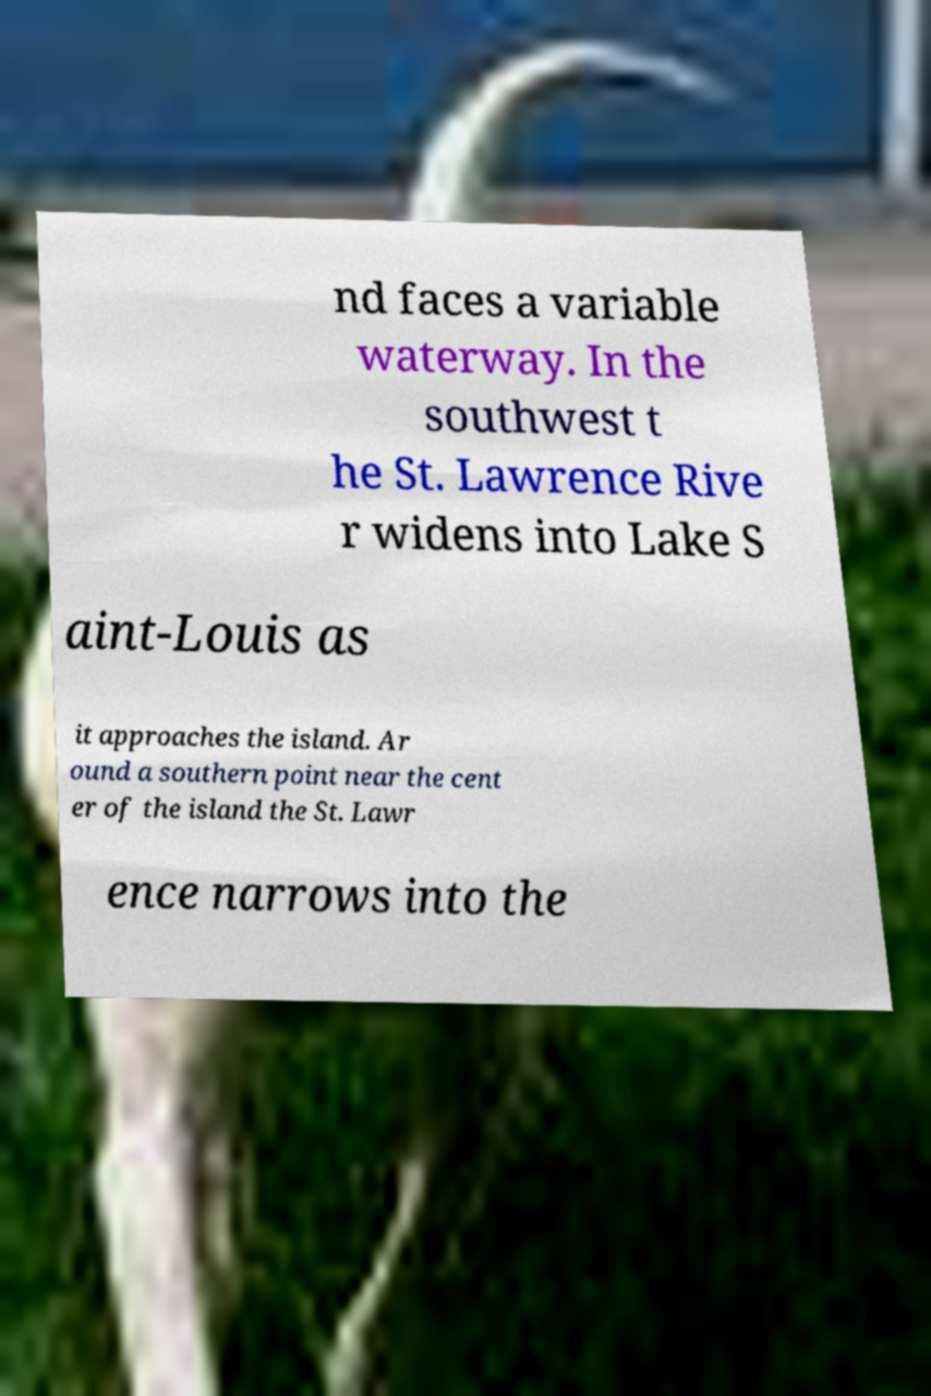Please identify and transcribe the text found in this image. nd faces a variable waterway. In the southwest t he St. Lawrence Rive r widens into Lake S aint-Louis as it approaches the island. Ar ound a southern point near the cent er of the island the St. Lawr ence narrows into the 